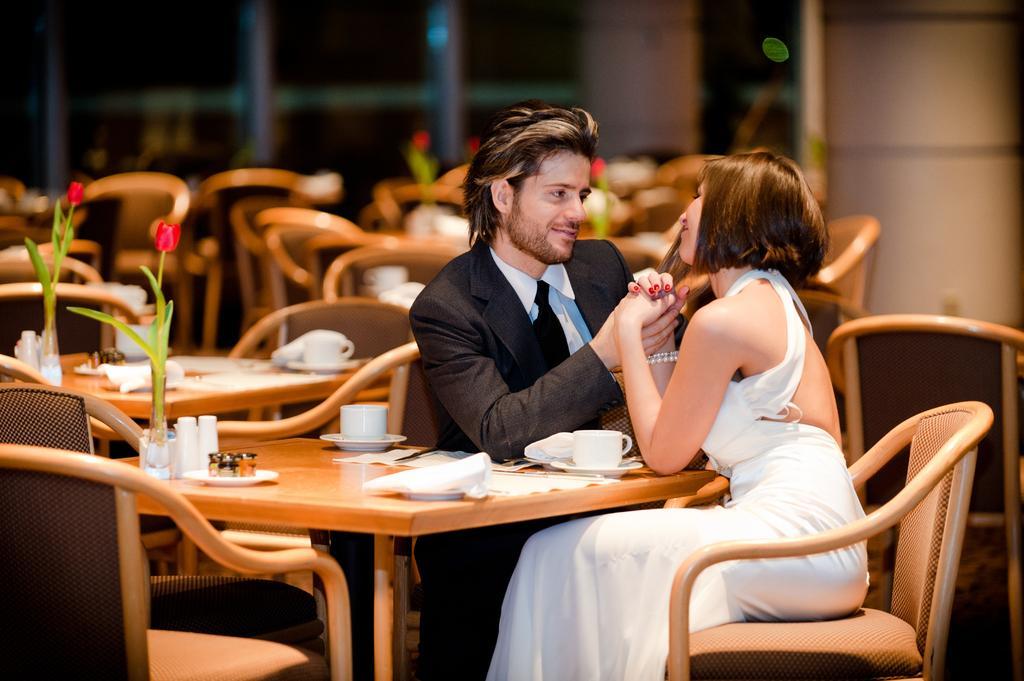Please provide a concise description of this image. This image is taken inside a room. In this image there are two people, a woman and a men. In the right side of the image a woman is sitting on a chair wearing a white frock. In the middle of the image a man is sitting on the chair wearing a suit and there is a table , on top of it there are few things and a flower. In this image there are many empty chairs and tables. At the background there is a wall. 